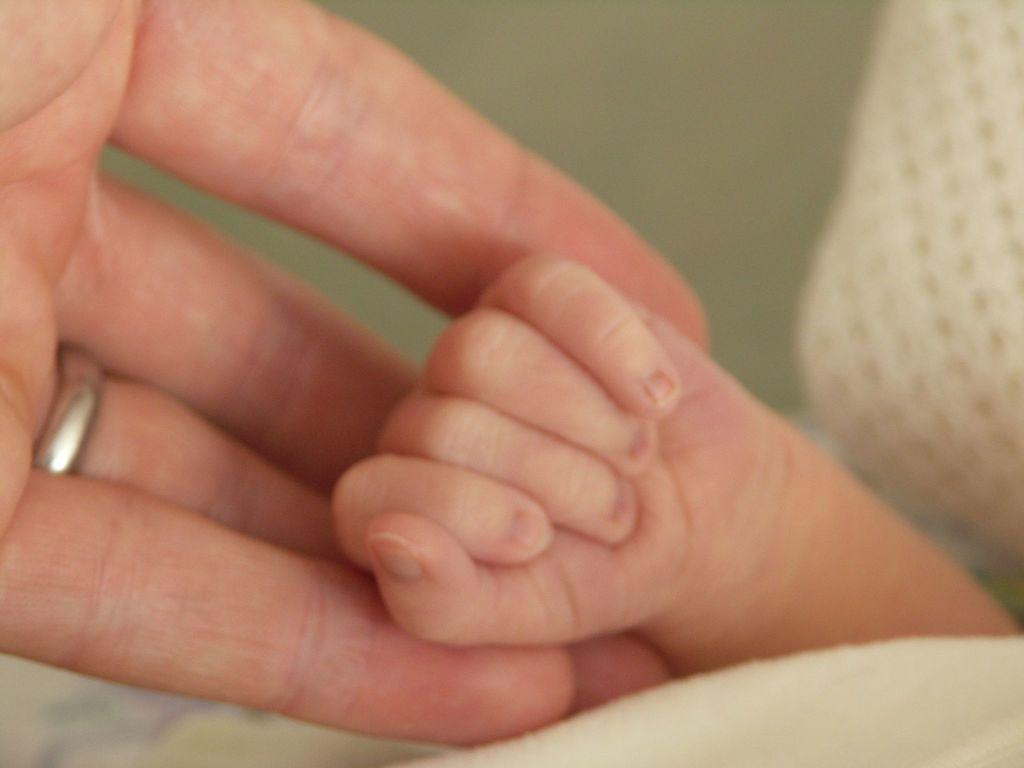What can be seen on the right side of the image? There is a child's hand on the right side of the image. What is on the left side of the image? There are fingers of a person on the left side of the image. Can you describe the person's ring finger? The person is wearing a ring on their ring finger. What type of pie is being served on the tree in the image? There is no pie or tree present in the image. What color is the silverware used by the person in the image? There is no silverware visible in the image. 